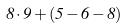<formula> <loc_0><loc_0><loc_500><loc_500>8 \cdot 9 + ( 5 - 6 - 8 )</formula> 